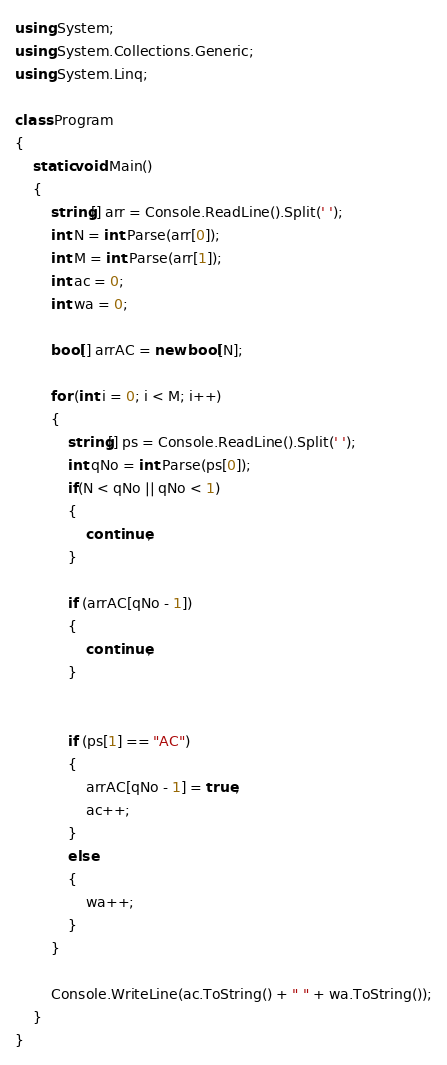Convert code to text. <code><loc_0><loc_0><loc_500><loc_500><_C#_>using System;
using System.Collections.Generic;
using System.Linq;

class Program
{
    static void Main()
    {
        string[] arr = Console.ReadLine().Split(' ');
        int N = int.Parse(arr[0]);
        int M = int.Parse(arr[1]);
        int ac = 0;
        int wa = 0;

        bool[] arrAC = new bool[N];

        for (int i = 0; i < M; i++)
        {
            string[] ps = Console.ReadLine().Split(' ');
            int qNo = int.Parse(ps[0]);
            if(N < qNo || qNo < 1)
            {
                continue;
            }

            if (arrAC[qNo - 1])
            {
                continue;
            }


            if (ps[1] == "AC")
            {
                arrAC[qNo - 1] = true;
                ac++;
            }
            else
            {
                wa++;
            }
        }

        Console.WriteLine(ac.ToString() + " " + wa.ToString());
    }
}</code> 